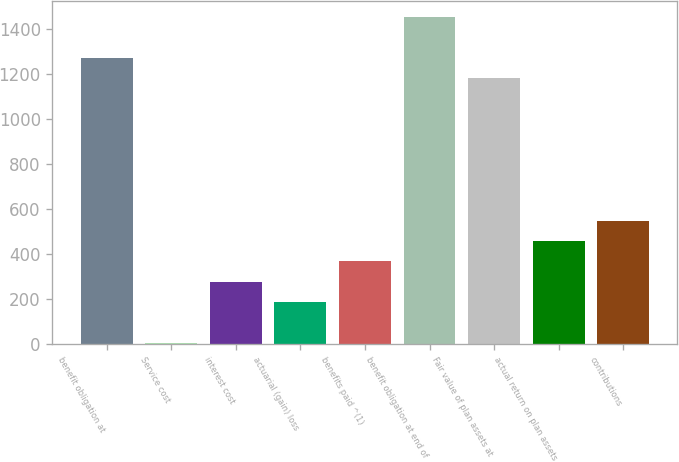<chart> <loc_0><loc_0><loc_500><loc_500><bar_chart><fcel>benefit obligation at<fcel>Service cost<fcel>interest cost<fcel>actuarial (gain) loss<fcel>benefits paid ^(1)<fcel>benefit obligation at end of<fcel>Fair value of plan assets at<fcel>actual return on plan assets<fcel>contributions<nl><fcel>1273.2<fcel>4.8<fcel>276.6<fcel>186<fcel>367.2<fcel>1454.4<fcel>1182.6<fcel>457.8<fcel>548.4<nl></chart> 